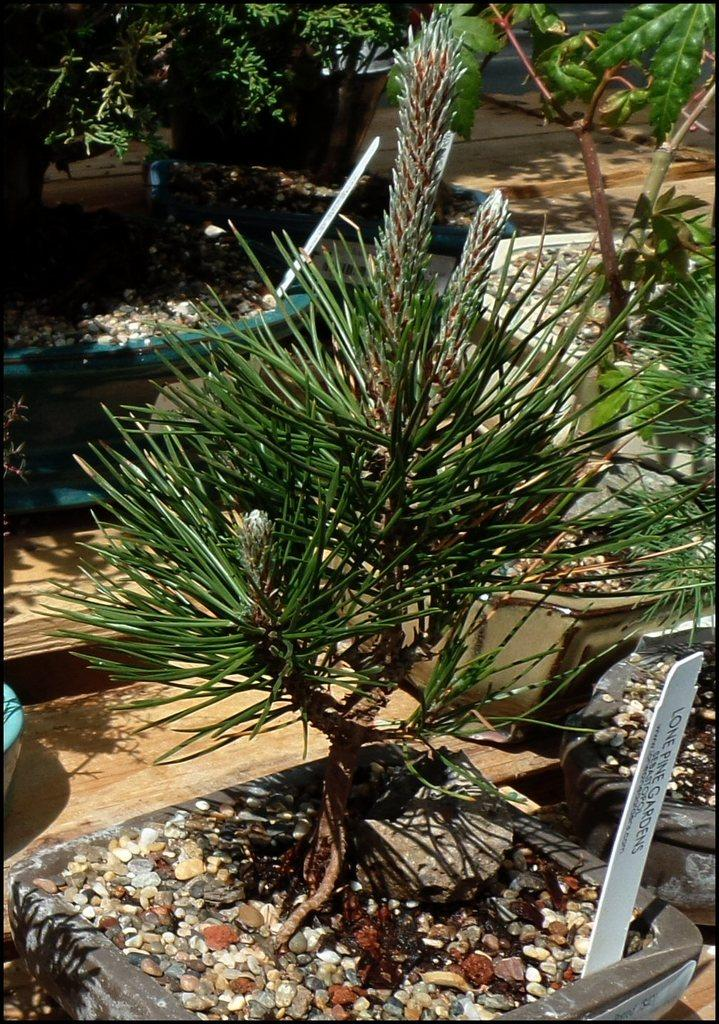What type of living organisms can be seen in the image? Plants can be seen in the image. What inorganic objects are present in the image? There are stones in the image. What is the white object with writing on it in the image? It is a white color board with writing on it. What type of glove is being used to prepare the meal in the image? There is no glove or meal present in the image. 